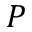<formula> <loc_0><loc_0><loc_500><loc_500>P</formula> 